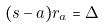Convert formula to latex. <formula><loc_0><loc_0><loc_500><loc_500>( s - a ) r _ { a } = \Delta</formula> 